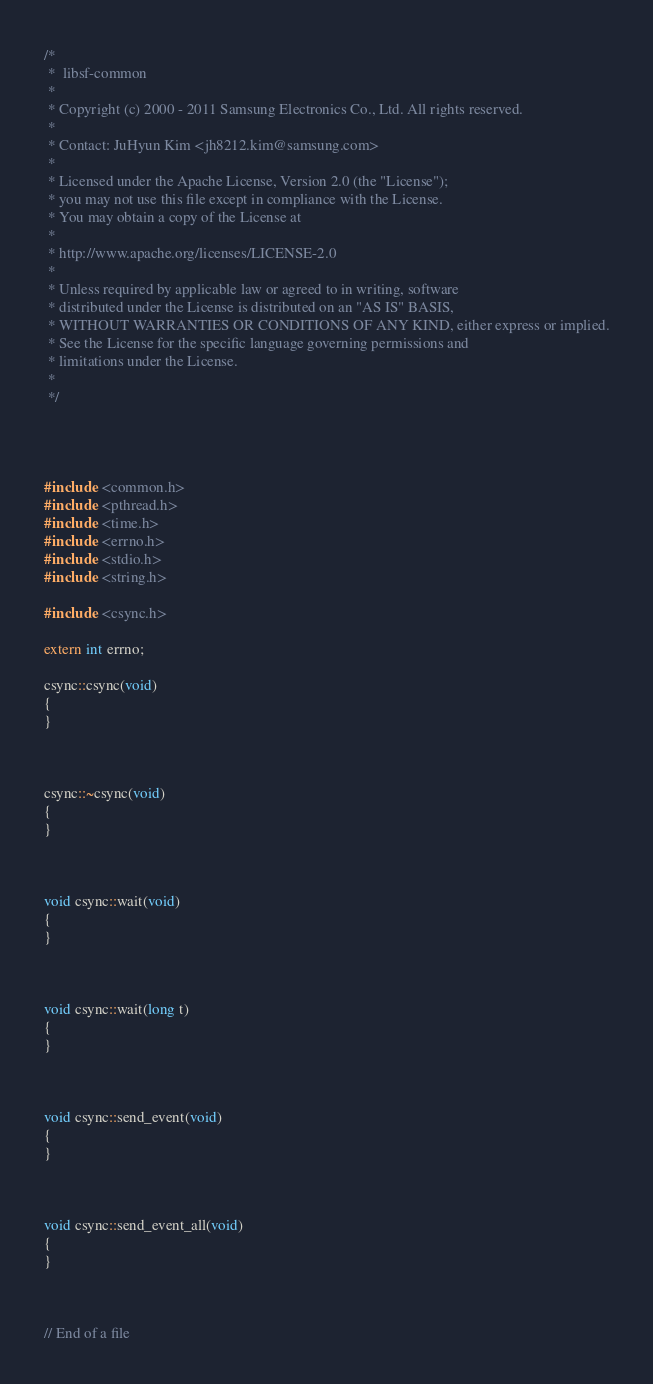<code> <loc_0><loc_0><loc_500><loc_500><_C++_>/*
 *  libsf-common
 *
 * Copyright (c) 2000 - 2011 Samsung Electronics Co., Ltd. All rights reserved.
 *
 * Contact: JuHyun Kim <jh8212.kim@samsung.com>
 * 
 * Licensed under the Apache License, Version 2.0 (the "License");
 * you may not use this file except in compliance with the License.
 * You may obtain a copy of the License at
 *
 * http://www.apache.org/licenses/LICENSE-2.0
 *
 * Unless required by applicable law or agreed to in writing, software
 * distributed under the License is distributed on an "AS IS" BASIS,
 * WITHOUT WARRANTIES OR CONDITIONS OF ANY KIND, either express or implied.
 * See the License for the specific language governing permissions and
 * limitations under the License.
 *
 */ 




#include <common.h>
#include <pthread.h>
#include <time.h>
#include <errno.h>
#include <stdio.h>
#include <string.h>

#include <csync.h>

extern int errno;

csync::csync(void)
{
}



csync::~csync(void)
{
}



void csync::wait(void)
{
}



void csync::wait(long t)
{
}



void csync::send_event(void)
{
}



void csync::send_event_all(void)
{
}



// End of a file
</code> 